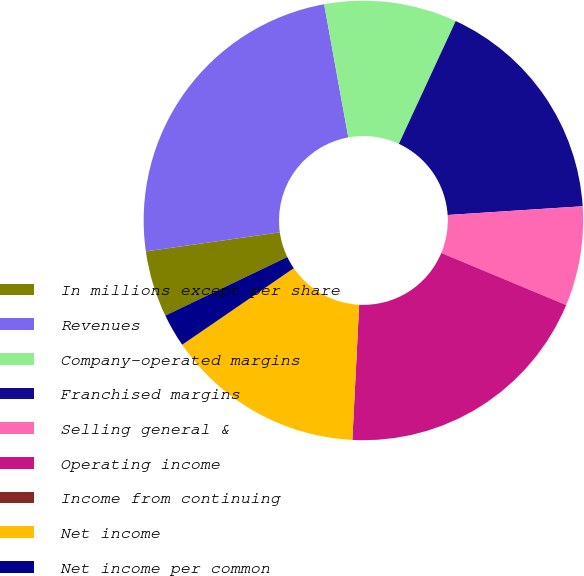<chart> <loc_0><loc_0><loc_500><loc_500><pie_chart><fcel>In millions except per share<fcel>Revenues<fcel>Company-operated margins<fcel>Franchised margins<fcel>Selling general &<fcel>Operating income<fcel>Income from continuing<fcel>Net income<fcel>Net income per common<nl><fcel>4.88%<fcel>24.39%<fcel>9.76%<fcel>17.07%<fcel>7.32%<fcel>19.51%<fcel>0.0%<fcel>14.63%<fcel>2.44%<nl></chart> 